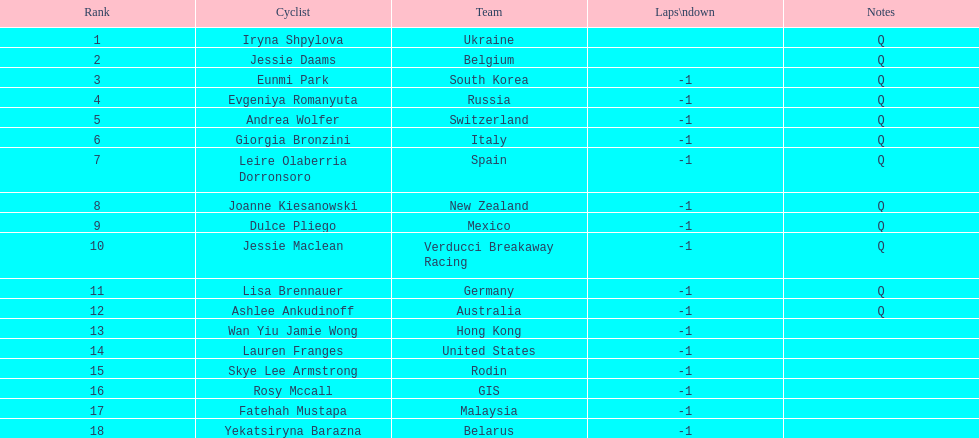How many cyclists do not have a lap count of -1? 2. 